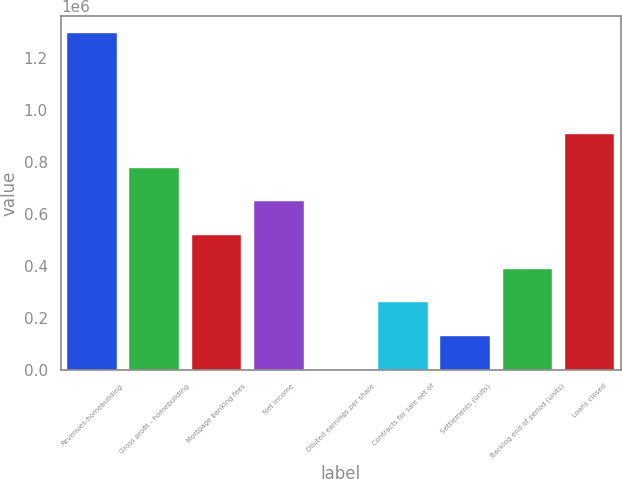Convert chart to OTSL. <chart><loc_0><loc_0><loc_500><loc_500><bar_chart><fcel>Revenues-homebuilding<fcel>Gross profit - homebuilding<fcel>Mortgage banking fees<fcel>Net income<fcel>Diluted earnings per share<fcel>Contracts for sale net of<fcel>Settlements (units)<fcel>Backlog end of period (units)<fcel>Loans closed<nl><fcel>1.29714e+06<fcel>778290<fcel>518864<fcel>648577<fcel>14.14<fcel>259439<fcel>129727<fcel>389152<fcel>908002<nl></chart> 